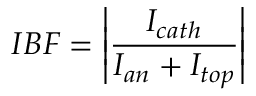Convert formula to latex. <formula><loc_0><loc_0><loc_500><loc_500>I B F = \left | \frac { I _ { c a t h } } { I _ { a n } + I _ { t o p } } \right |</formula> 